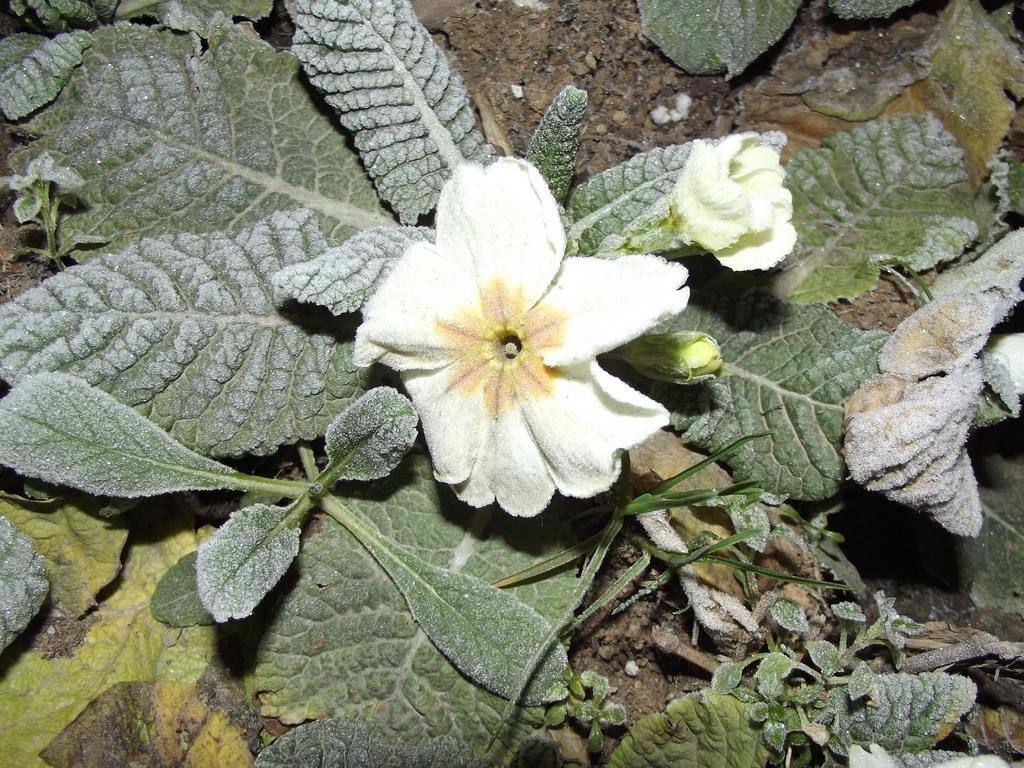What type of living organisms can be seen in the image? There are flowers in the image. What colors are present on the flowers? The flowers have cream, yellow, and orange colors. What color are the plants in the image? The plants in the image are green. What can be seen in the background of the image? The ground is visible in the background of the image. Can you tell me how much credit the stranger is offering in the image? There is no mention of credit or a stranger in the image; it features flowers and plants. What type of knife is being used to cut the flowers in the image? There is no knife present in the image; it only shows flowers and plants. 